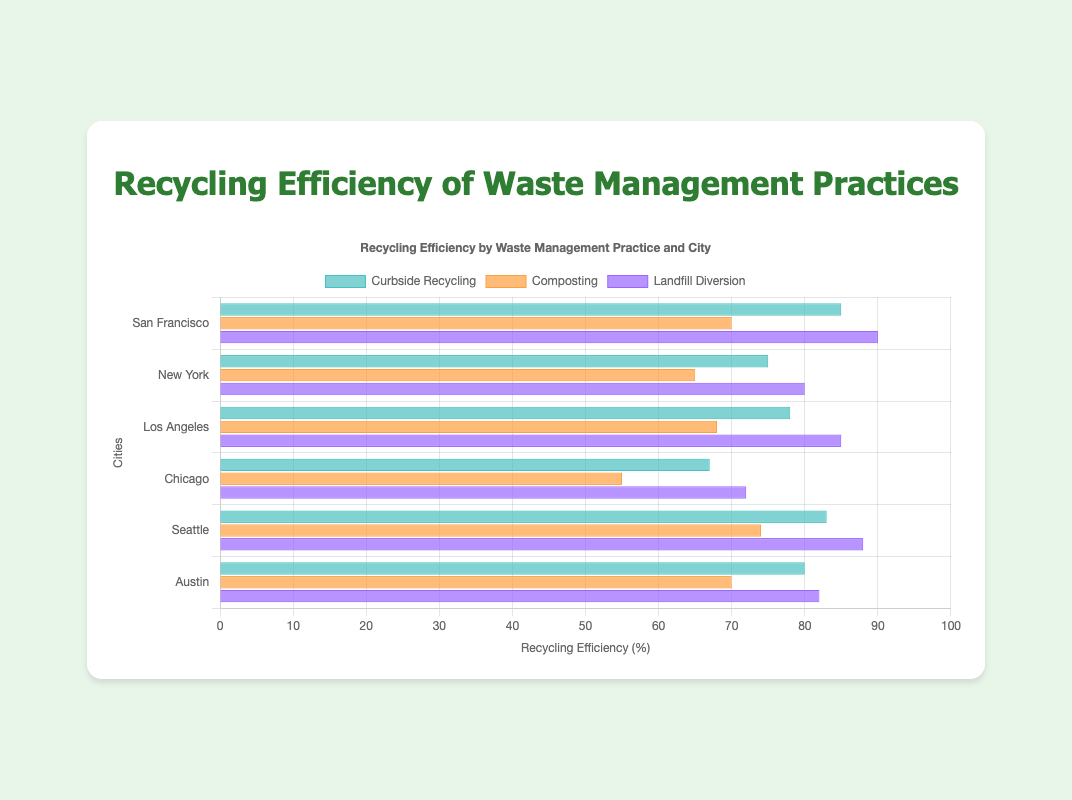What city has the highest recycling efficiency for Curbside Recycling? By examining the green bars representing Curbside Recycling across all cities, the one with the highest value must be identified. San Francisco's green bar is the tallest at 85%.
Answer: San Francisco Which city has the lowest recycling efficiency for Composting? By examining the orange bars representing Composting across all cities, the one with the lowest value must be identified. Chicago's orange bar is the lowest at 55%.
Answer: Chicago What is the difference in recycling efficiency between Composting and Landfill Diversion in Los Angeles? Identify the values for Composting and Landfill Diversion in Los Angeles: Composting is 68%, and Landfill Diversion is 85%. So, the difference is 85% - 68% = 17%.
Answer: 17% Which city has a closer recycling efficiency between Curbside Recycling and Landfill Diversion: Seattle or Austin? Examine the values for Curbside Recycling and Landfill Diversion in both cities: 
Seattle: Curbside Recycling is 83%, Landfill Diversion is 88%, difference is 88% - 83% = 5%.
Austin: Curbside Recycling is 80%, Landfill Diversion is 82%, difference is 82% - 80% = 2%.
Austin has a smaller difference of 2%.
Answer: Austin Across all cities, which waste management practice generally shows the highest recycling efficiency? By comparing the three practices (Curbside Recycling, Composting, and Landfill Diversion) across all cities, observe which practice consistently has the highest values. Landfill Diversion generally shows the highest efficiency.
Answer: Landfill Diversion Which city has the largest range in recycling efficiency among the three practices? Calculate the range for each city by finding the difference between the highest and lowest efficiencies among the three practices:
San Francisco: 90% - 70% = 20%
New York: 80% - 65% = 15%
Los Angeles: 85% - 68% = 17%
Chicago: 72% - 55% = 17%
Seattle: 88% - 74% = 14%
Austin: 82% - 70% = 12%
San Francisco has the largest range at 20%.
Answer: San Francisco Which city has the closest average recycling efficiency across all three practices? Calculate the average efficiency for each city by summing and dividing by three:
San Francisco: (85% + 70% + 90%)/3 = 81.67%
New York: (75% + 65% + 80%)/3 = 73.33%
Los Angeles: (78% + 68% + 85%)/3 = 77%
Chicago: (67% + 55% + 72%)/3 = 64.67%
Seattle: (83% + 74% + 88%)/3 = 81.67%
Austin: (80% + 70% + 82%)/3 = 77.33%
San Francisco and Seattle both have the closest average at 81.67%.
Answer: San Francisco and Seattle If we sum up the recycling efficiency for all waste management practices for each city, which city has the highest sum? Sum the recycling efficiencies for each city:
San Francisco: 85% + 70% + 90% = 245%
New York: 75% + 65% + 80% = 220%
Los Angeles: 78% + 68% + 85% = 231%
Chicago: 67% + 55% + 72% = 194%
Seattle: 83% + 74% + 88% = 245%
Austin: 80% + 70% + 82% = 232%
San Francisco and Seattle have the highest sum at 245%.
Answer: San Francisco and Seattle 